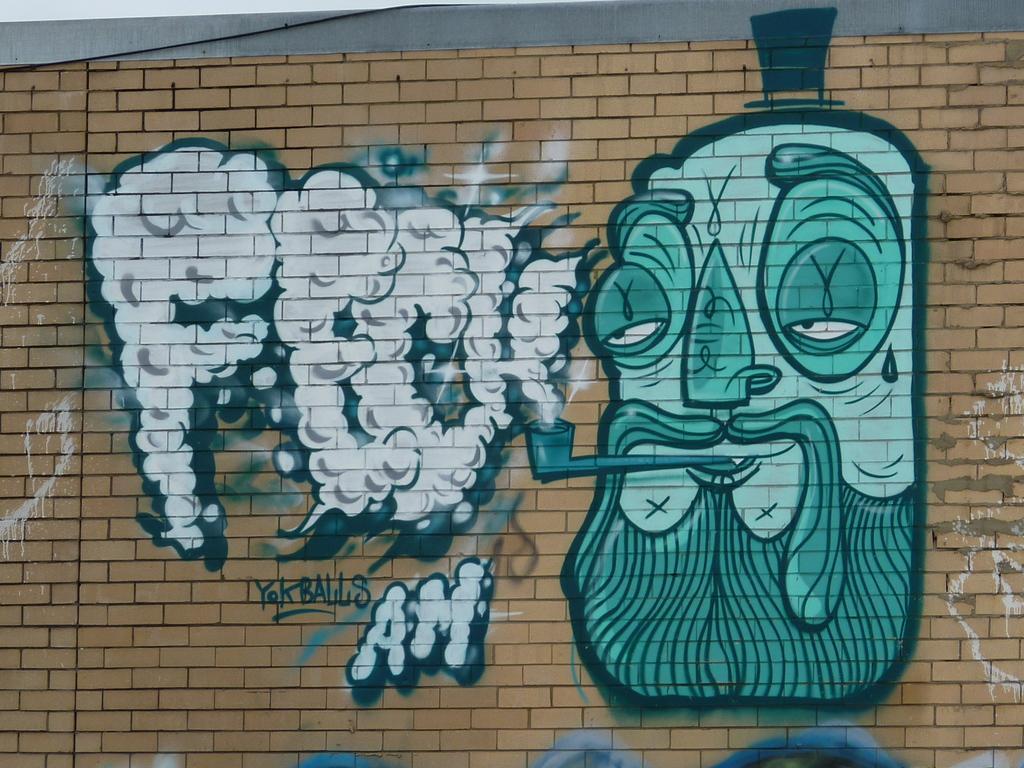Could you give a brief overview of what you see in this image? In the foreground of this image, there is graffiti painting on the wall. 